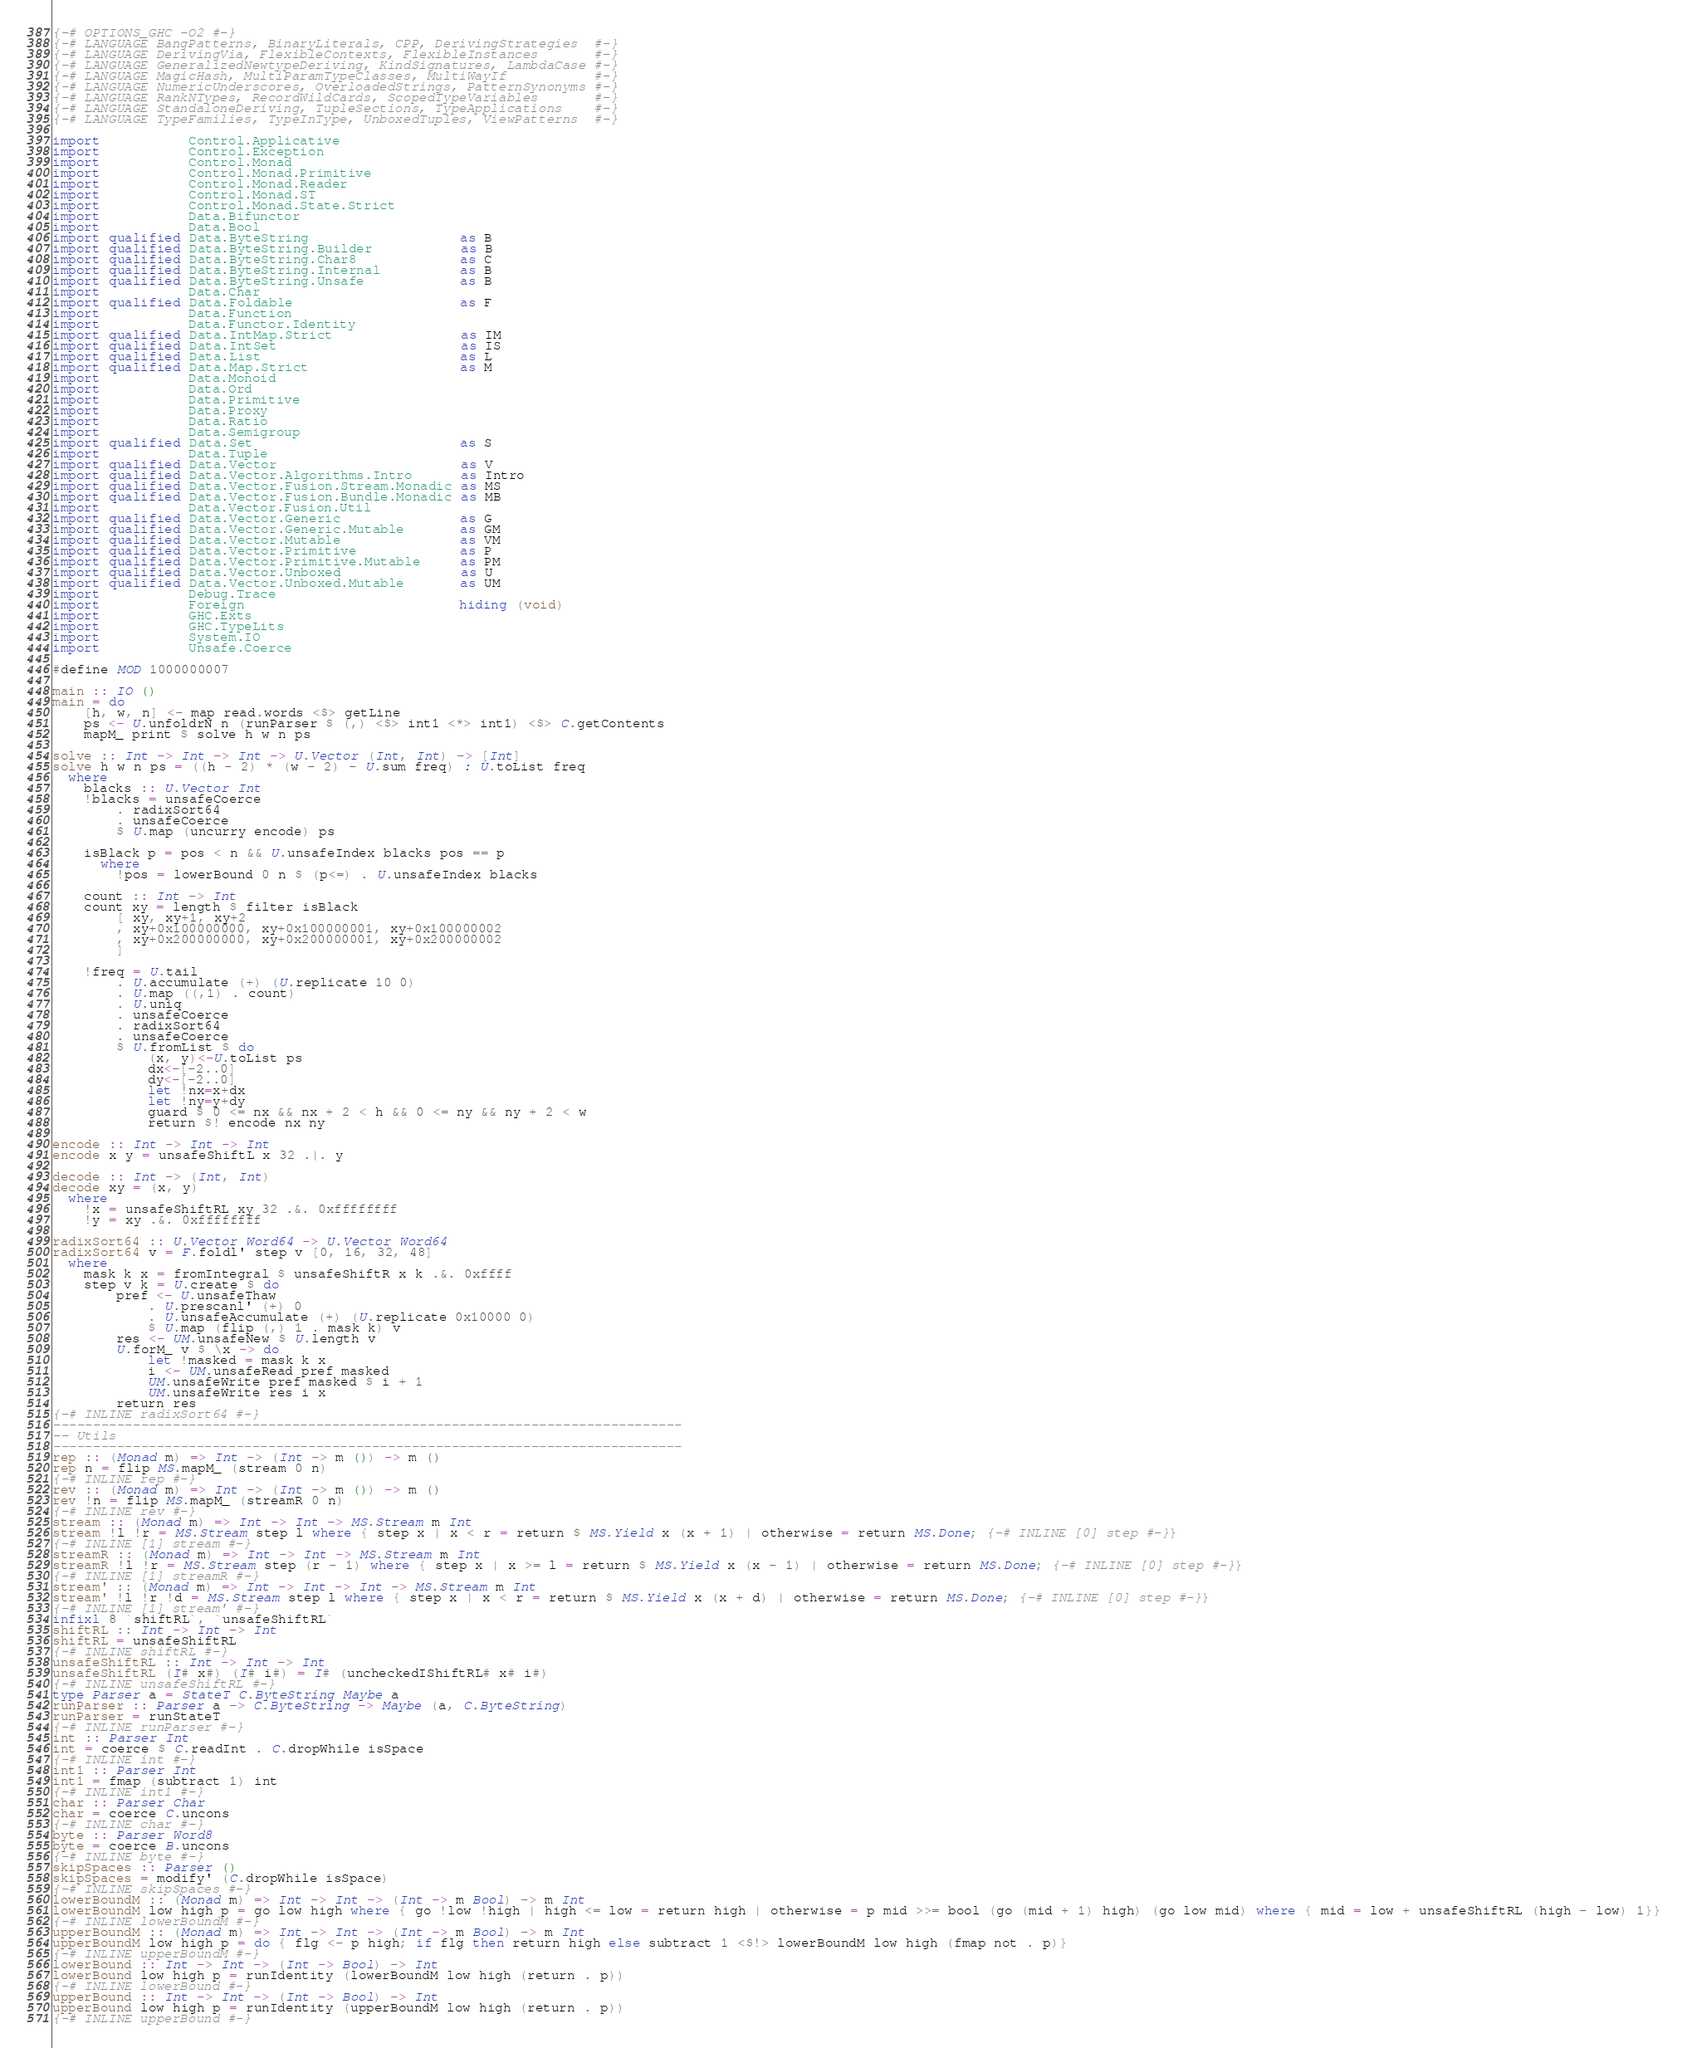<code> <loc_0><loc_0><loc_500><loc_500><_Haskell_>{-# OPTIONS_GHC -O2 #-}
{-# LANGUAGE BangPatterns, BinaryLiterals, CPP, DerivingStrategies  #-}
{-# LANGUAGE DerivingVia, FlexibleContexts, FlexibleInstances       #-}
{-# LANGUAGE GeneralizedNewtypeDeriving, KindSignatures, LambdaCase #-}
{-# LANGUAGE MagicHash, MultiParamTypeClasses, MultiWayIf           #-}
{-# LANGUAGE NumericUnderscores, OverloadedStrings, PatternSynonyms #-}
{-# LANGUAGE RankNTypes, RecordWildCards, ScopedTypeVariables       #-}
{-# LANGUAGE StandaloneDeriving, TupleSections, TypeApplications    #-}
{-# LANGUAGE TypeFamilies, TypeInType, UnboxedTuples, ViewPatterns  #-}

import           Control.Applicative
import           Control.Exception
import           Control.Monad
import           Control.Monad.Primitive
import           Control.Monad.Reader
import           Control.Monad.ST
import           Control.Monad.State.Strict
import           Data.Bifunctor
import           Data.Bool
import qualified Data.ByteString                   as B
import qualified Data.ByteString.Builder           as B
import qualified Data.ByteString.Char8             as C
import qualified Data.ByteString.Internal          as B
import qualified Data.ByteString.Unsafe            as B
import           Data.Char
import qualified Data.Foldable                     as F
import           Data.Function
import           Data.Functor.Identity
import qualified Data.IntMap.Strict                as IM
import qualified Data.IntSet                       as IS
import qualified Data.List                         as L
import qualified Data.Map.Strict                   as M
import           Data.Monoid
import           Data.Ord
import           Data.Primitive
import           Data.Proxy
import           Data.Ratio
import           Data.Semigroup
import qualified Data.Set                          as S
import           Data.Tuple
import qualified Data.Vector                       as V
import qualified Data.Vector.Algorithms.Intro      as Intro
import qualified Data.Vector.Fusion.Stream.Monadic as MS
import qualified Data.Vector.Fusion.Bundle.Monadic as MB
import           Data.Vector.Fusion.Util
import qualified Data.Vector.Generic               as G
import qualified Data.Vector.Generic.Mutable       as GM
import qualified Data.Vector.Mutable               as VM
import qualified Data.Vector.Primitive             as P
import qualified Data.Vector.Primitive.Mutable     as PM
import qualified Data.Vector.Unboxed               as U
import qualified Data.Vector.Unboxed.Mutable       as UM
import           Debug.Trace
import           Foreign                           hiding (void)
import           GHC.Exts
import           GHC.TypeLits
import           System.IO
import           Unsafe.Coerce

#define MOD 1000000007

main :: IO ()
main = do
    [h, w, n] <- map read.words <$> getLine
    ps <- U.unfoldrN n (runParser $ (,) <$> int1 <*> int1) <$> C.getContents
    mapM_ print $ solve h w n ps

solve :: Int -> Int -> Int -> U.Vector (Int, Int) -> [Int]
solve h w n ps = ((h - 2) * (w - 2) - U.sum freq) : U.toList freq
  where
    blacks :: U.Vector Int
    !blacks = unsafeCoerce
        . radixSort64
        . unsafeCoerce
        $ U.map (uncurry encode) ps

    isBlack p = pos < n && U.unsafeIndex blacks pos == p
      where
        !pos = lowerBound 0 n $ (p<=) . U.unsafeIndex blacks

    count :: Int -> Int
    count xy = length $ filter isBlack
        [ xy, xy+1, xy+2
        , xy+0x100000000, xy+0x100000001, xy+0x100000002
        , xy+0x200000000, xy+0x200000001, xy+0x200000002
        ]

    !freq = U.tail
        . U.accumulate (+) (U.replicate 10 0)
        . U.map ((,1) . count)
        . U.uniq
        . unsafeCoerce
        . radixSort64
        . unsafeCoerce
        $ U.fromList $ do
            (x, y)<-U.toList ps
            dx<-[-2..0]
            dy<-[-2..0]
            let !nx=x+dx
            let !ny=y+dy
            guard $ 0 <= nx && nx + 2 < h && 0 <= ny && ny + 2 < w
            return $! encode nx ny

encode :: Int -> Int -> Int
encode x y = unsafeShiftL x 32 .|. y

decode :: Int -> (Int, Int)
decode xy = (x, y)
  where
    !x = unsafeShiftRL xy 32 .&. 0xffffffff
    !y = xy .&. 0xffffffff

radixSort64 :: U.Vector Word64 -> U.Vector Word64
radixSort64 v = F.foldl' step v [0, 16, 32, 48]
  where
    mask k x = fromIntegral $ unsafeShiftR x k .&. 0xffff
    step v k = U.create $ do
        pref <- U.unsafeThaw
            . U.prescanl' (+) 0
            . U.unsafeAccumulate (+) (U.replicate 0x10000 0)
            $ U.map (flip (,) 1 . mask k) v
        res <- UM.unsafeNew $ U.length v
        U.forM_ v $ \x -> do
            let !masked = mask k x
            i <- UM.unsafeRead pref masked
            UM.unsafeWrite pref masked $ i + 1
            UM.unsafeWrite res i x
        return res
{-# INLINE radixSort64 #-}
-------------------------------------------------------------------------------
-- Utils
-------------------------------------------------------------------------------
rep :: (Monad m) => Int -> (Int -> m ()) -> m ()
rep n = flip MS.mapM_ (stream 0 n)
{-# INLINE rep #-}
rev :: (Monad m) => Int -> (Int -> m ()) -> m ()
rev !n = flip MS.mapM_ (streamR 0 n)
{-# INLINE rev #-}
stream :: (Monad m) => Int -> Int -> MS.Stream m Int
stream !l !r = MS.Stream step l where { step x | x < r = return $ MS.Yield x (x + 1) | otherwise = return MS.Done; {-# INLINE [0] step #-}}
{-# INLINE [1] stream #-}
streamR :: (Monad m) => Int -> Int -> MS.Stream m Int
streamR !l !r = MS.Stream step (r - 1) where { step x | x >= l = return $ MS.Yield x (x - 1) | otherwise = return MS.Done; {-# INLINE [0] step #-}}
{-# INLINE [1] streamR #-}
stream' :: (Monad m) => Int -> Int -> Int -> MS.Stream m Int
stream' !l !r !d = MS.Stream step l where { step x | x < r = return $ MS.Yield x (x + d) | otherwise = return MS.Done; {-# INLINE [0] step #-}}
{-# INLINE [1] stream' #-}
infixl 8 `shiftRL`, `unsafeShiftRL`
shiftRL :: Int -> Int -> Int
shiftRL = unsafeShiftRL
{-# INLINE shiftRL #-}
unsafeShiftRL :: Int -> Int -> Int
unsafeShiftRL (I# x#) (I# i#) = I# (uncheckedIShiftRL# x# i#)
{-# INLINE unsafeShiftRL #-}
type Parser a = StateT C.ByteString Maybe a
runParser :: Parser a -> C.ByteString -> Maybe (a, C.ByteString)
runParser = runStateT
{-# INLINE runParser #-}
int :: Parser Int
int = coerce $ C.readInt . C.dropWhile isSpace
{-# INLINE int #-}
int1 :: Parser Int
int1 = fmap (subtract 1) int
{-# INLINE int1 #-}
char :: Parser Char
char = coerce C.uncons
{-# INLINE char #-}
byte :: Parser Word8
byte = coerce B.uncons
{-# INLINE byte #-}
skipSpaces :: Parser ()
skipSpaces = modify' (C.dropWhile isSpace)
{-# INLINE skipSpaces #-}
lowerBoundM :: (Monad m) => Int -> Int -> (Int -> m Bool) -> m Int
lowerBoundM low high p = go low high where { go !low !high | high <= low = return high | otherwise = p mid >>= bool (go (mid + 1) high) (go low mid) where { mid = low + unsafeShiftRL (high - low) 1}}
{-# INLINE lowerBoundM #-}
upperBoundM :: (Monad m) => Int -> Int -> (Int -> m Bool) -> m Int
upperBoundM low high p = do { flg <- p high; if flg then return high else subtract 1 <$!> lowerBoundM low high (fmap not . p)}
{-# INLINE upperBoundM #-}
lowerBound :: Int -> Int -> (Int -> Bool) -> Int
lowerBound low high p = runIdentity (lowerBoundM low high (return . p))
{-# INLINE lowerBound #-}
upperBound :: Int -> Int -> (Int -> Bool) -> Int
upperBound low high p = runIdentity (upperBoundM low high (return . p))
{-# INLINE upperBound #-}
</code> 